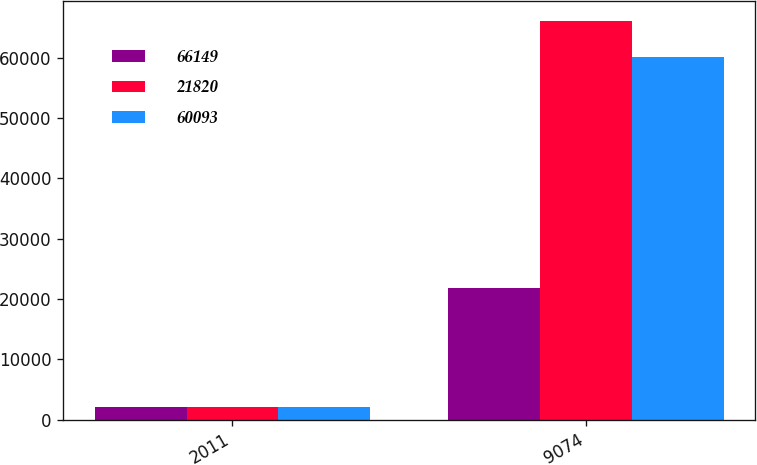<chart> <loc_0><loc_0><loc_500><loc_500><stacked_bar_chart><ecel><fcel>2011<fcel>9074<nl><fcel>66149<fcel>2010<fcel>21820<nl><fcel>21820<fcel>2009<fcel>66149<nl><fcel>60093<fcel>2008<fcel>60093<nl></chart> 